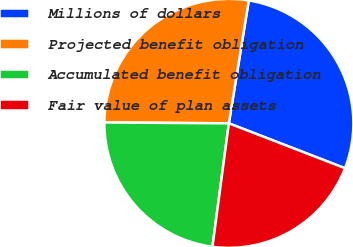Convert chart to OTSL. <chart><loc_0><loc_0><loc_500><loc_500><pie_chart><fcel>Millions of dollars<fcel>Projected benefit obligation<fcel>Accumulated benefit obligation<fcel>Fair value of plan assets<nl><fcel>28.31%<fcel>27.44%<fcel>23.01%<fcel>21.23%<nl></chart> 